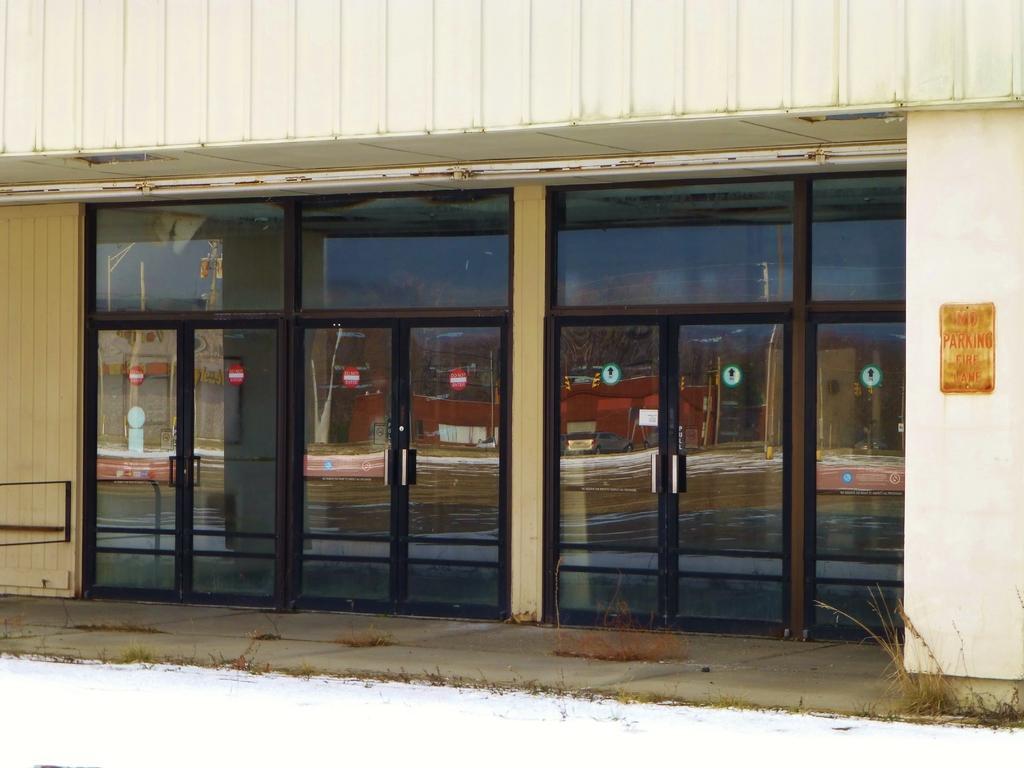Can you describe this image briefly? In this image I can see a building, few doors and few sign boards on it. On the right side of the image, I can see a yellow colour board on the wall and on it I can see something is written. 